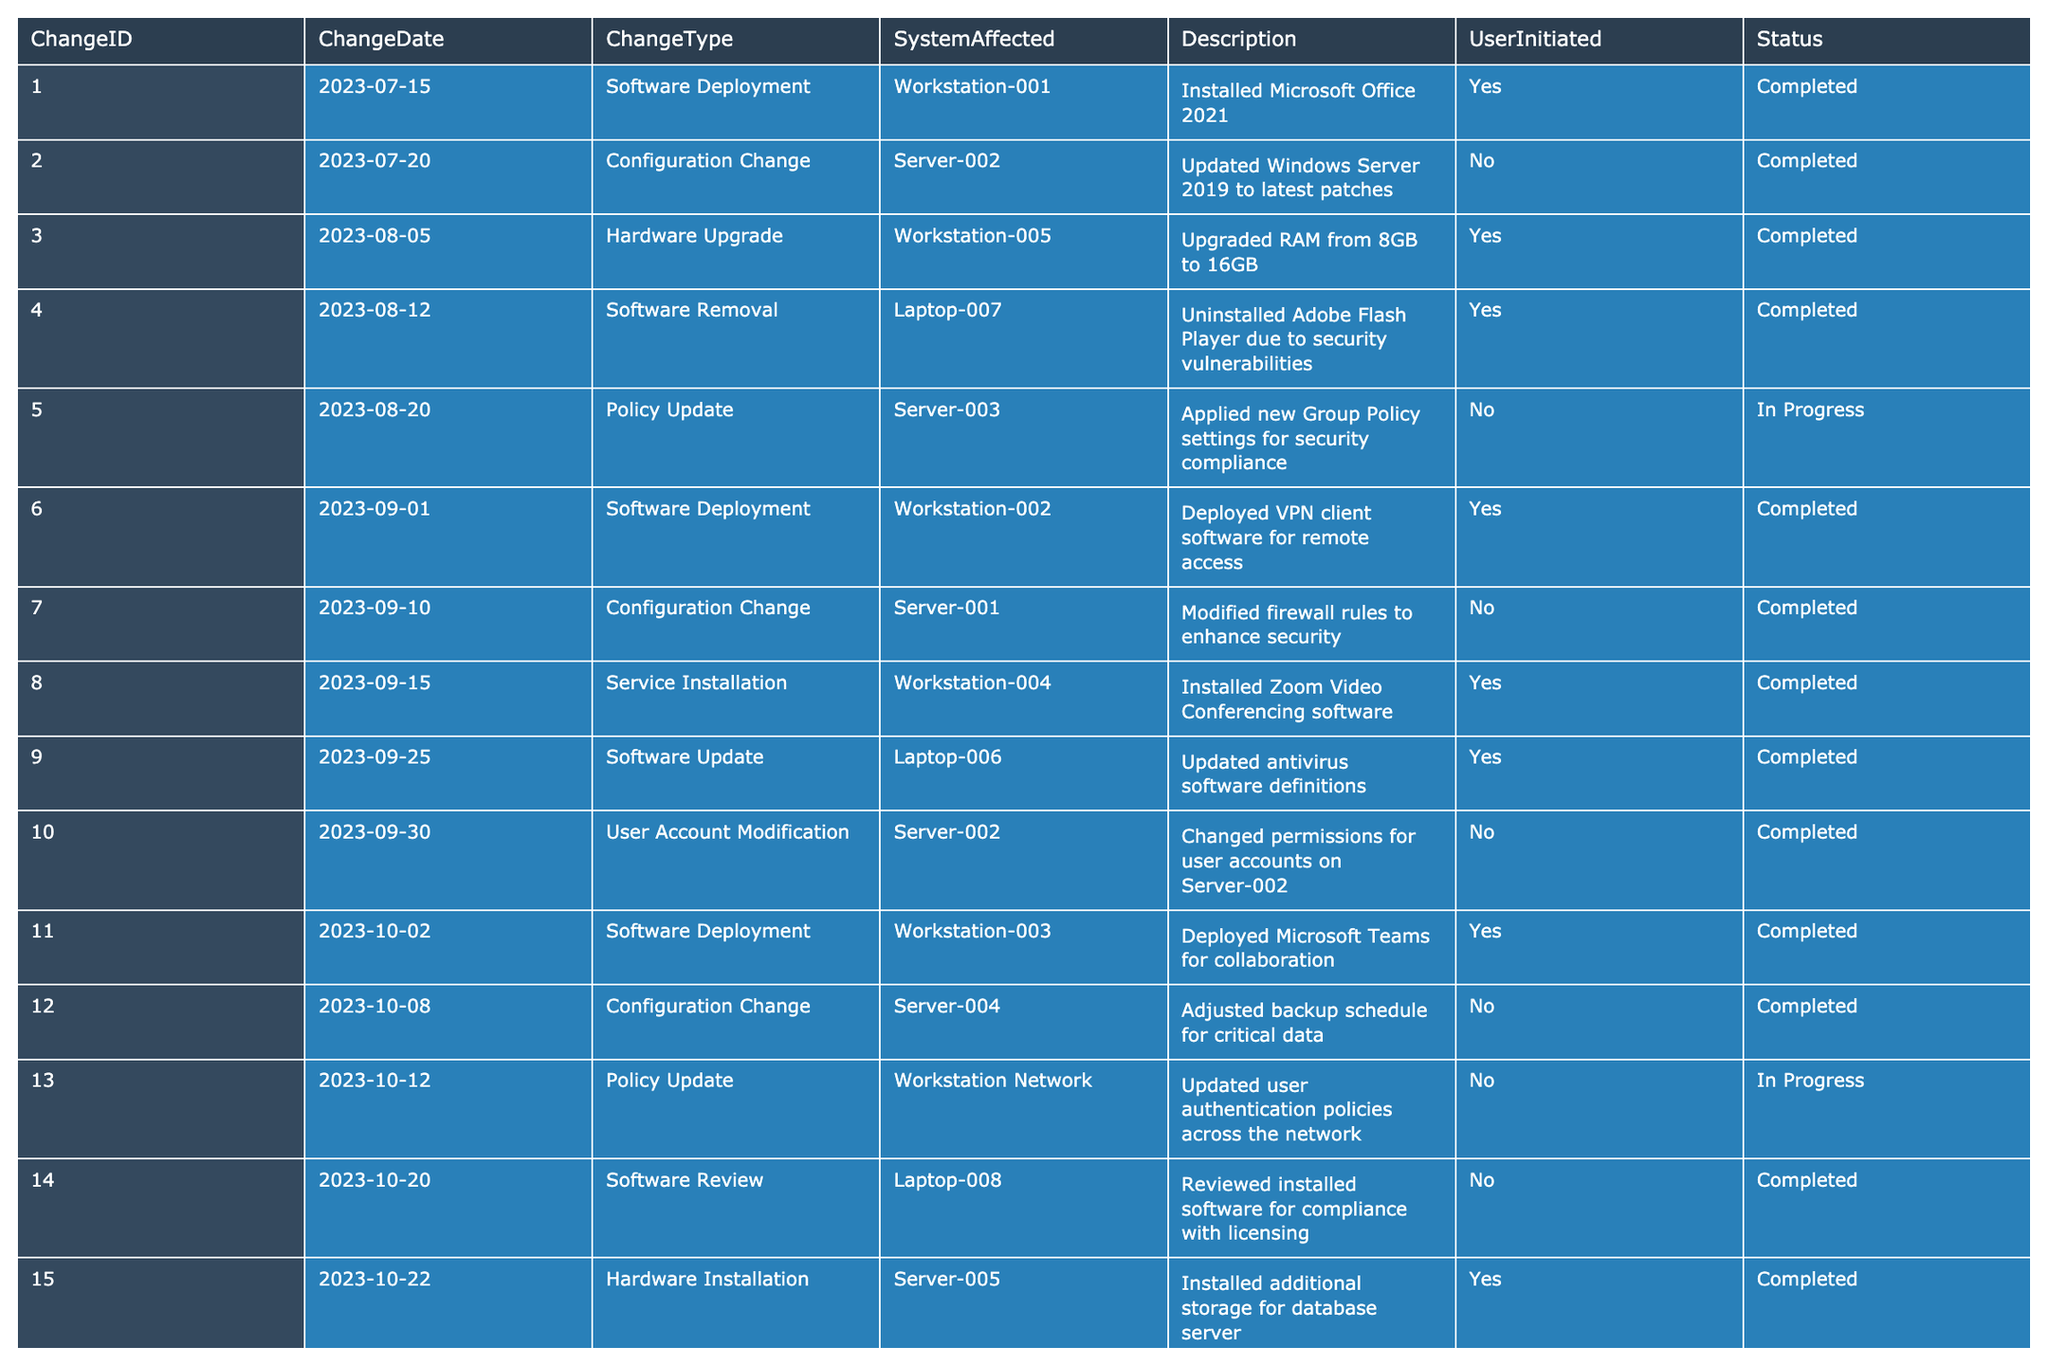What is the total number of system changes recorded in the last quarter? There are 15 entries listed in the table. Each entry represents a system change, so I counted them directly to find the total number of changes.
Answer: 15 How many changes were initiated by users? By scanning the UserInitiated column, I identified the entries marked as "Yes." There are 8 user-initiated changes.
Answer: 8 Which system was affected by the most recent change? The latest change is recorded on "2023-10-22" affecting "Server-005." I located the row with the latest ChangeDate and checked the corresponding SystemAffected.
Answer: Server-005 How many changes are still in progress? I looked at the Status column and counted the entries marked as "In Progress." There are 2 changes with this status.
Answer: 2 What type of change occurred most frequently? I examined the ChangeType column, counting occurrences of each type: Software Deployment (4), Configuration Change (3), Hardware Upgrade (2), Software Removal (1), Policy Update (2), Service Installation (1), Software Update (1), User Account Modification (1), Software Review (1), Hardware Installation (1). The type that appears the most is "Software Deployment" with 4 occurrences.
Answer: Software Deployment Were any changes related to security vulnerabilities? I reviewed the Description column for mentions of security vulnerabilities. The entry describing the removal of Adobe Flash Player indicated it was due to security vulnerabilities. Hence, yes, there was one such change.
Answer: Yes Which workstation had both a software deployment and a configuration change in this quarter? I checked the SystemAffected column for "Workstation" entries. I found "Workstation-002" with a software deployment, but no configuration change for that specific workstation existed in this quarter; thus, I searched again and identified that "Workstation-001" only had a software deployment. Neither had both types of changes.
Answer: None What is the count of changes made to servers compared to workstations? By filtering the table, I counted 6 changes related to servers (IDs 2, 5, 7, 10, 12, 15) and 7 changes related to workstations (IDs 1, 3, 6, 8, 11, 13, 14). The count shows that there were more workstation changes.
Answer: Workstations had more changes Is any policy update still in progress and what does it entail? I looked for policy updates marked as "In Progress" in the Status column. There is one such entry (ChangeID 13), which mentions updating user authentication policies across the network.
Answer: Yes, it is updating user authentication policies What percentage of hardware-related changes were completed? Out of 3 hardware-related changes (IDs 3, 5, 15), 2 were completed (IDs 3 and 15). To calculate the percentage, I divided the number of completed changes by total hardware changes (2/3) and multiplied by 100, yielding approximately 67%.
Answer: Approximately 67% 